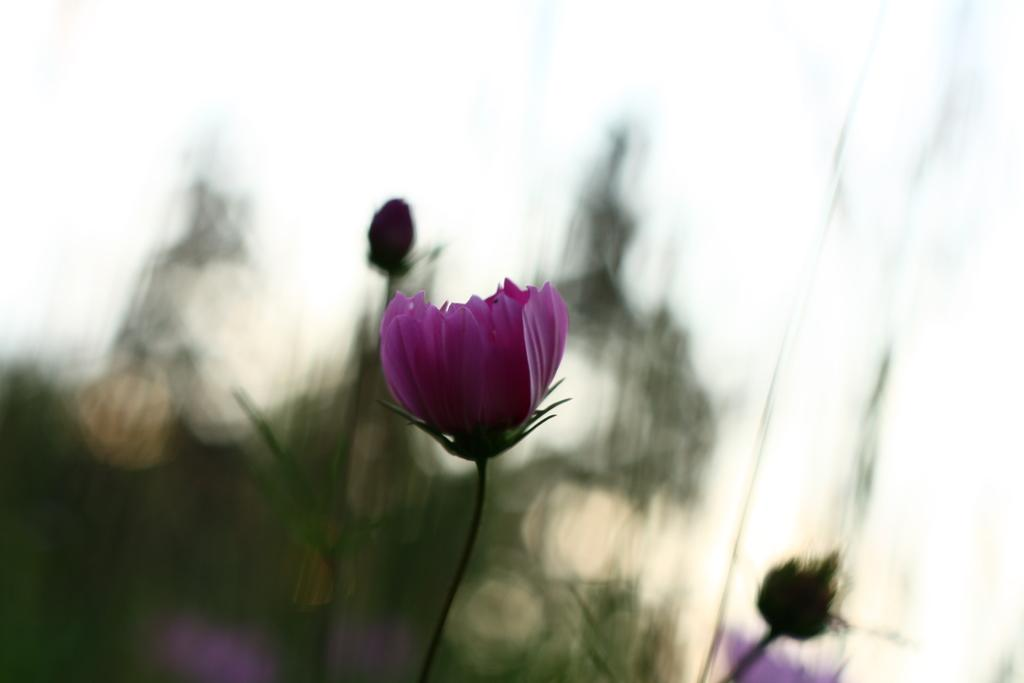What type of flowers can be seen in the image? There are purple color flowers in the image. Can you describe the quality of the image? The image is blurry from the background. What type of juice is being served by the aunt in the image? There is no aunt or juice present in the image; it only features purple color flowers. 